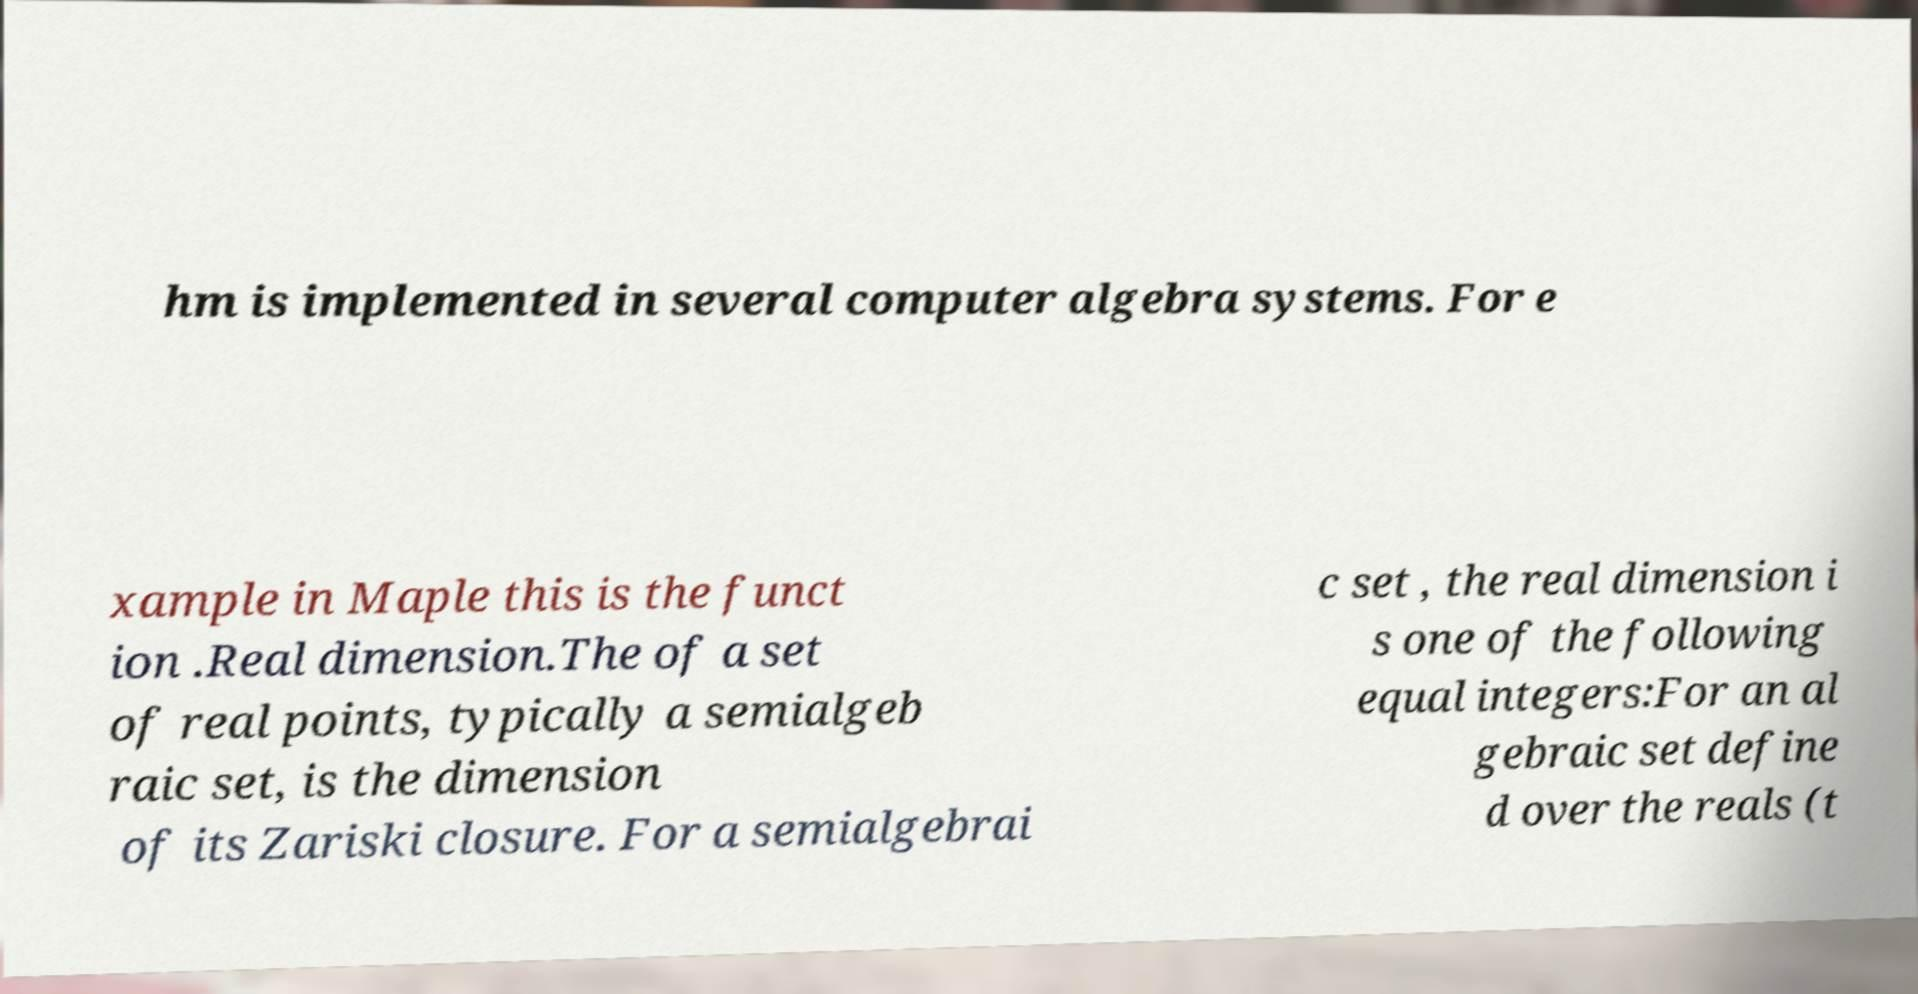For documentation purposes, I need the text within this image transcribed. Could you provide that? hm is implemented in several computer algebra systems. For e xample in Maple this is the funct ion .Real dimension.The of a set of real points, typically a semialgeb raic set, is the dimension of its Zariski closure. For a semialgebrai c set , the real dimension i s one of the following equal integers:For an al gebraic set define d over the reals (t 